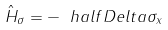<formula> <loc_0><loc_0><loc_500><loc_500>\hat { H } _ { \sigma } = - \ h a l f D e l t a \sigma _ { x }</formula> 